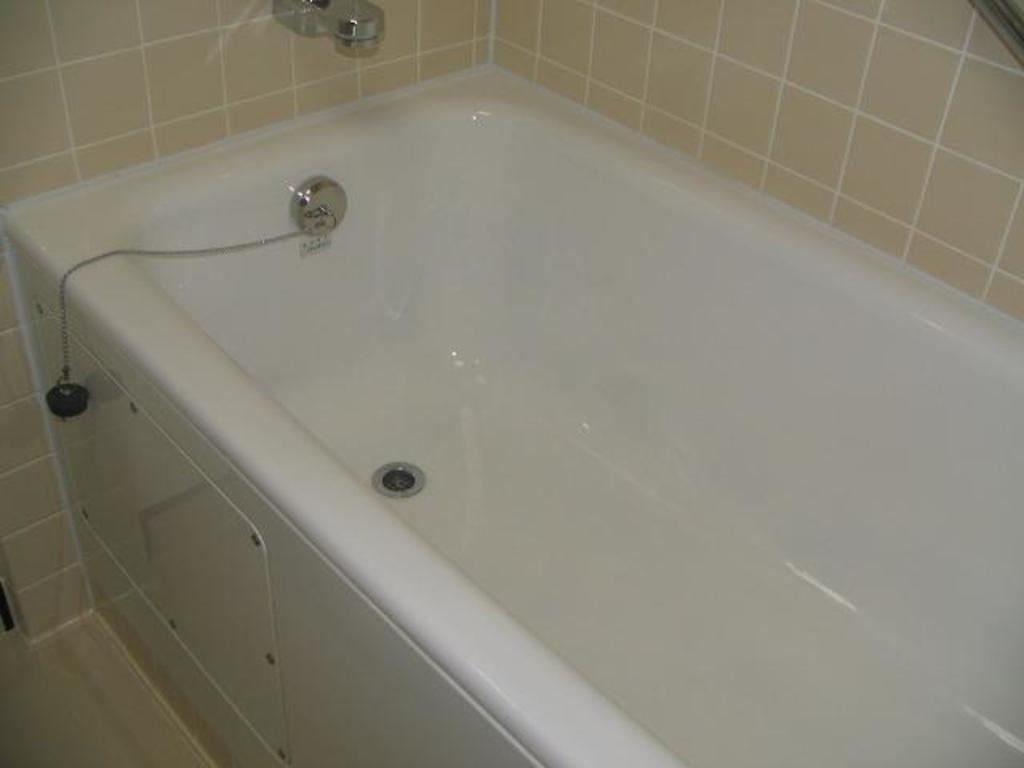What is the main object in the image? There is a bathtub in the image. Where is the tap located in the image? There is a tap on the wall in the image. What part of the room can be seen in the image? The floor is visible in the image. What type of fruit is being served in the image? There is no fruit present in the image; it features a bathtub, a tap, and the floor. Can you see a truck in the image? There is no truck present in the image. 